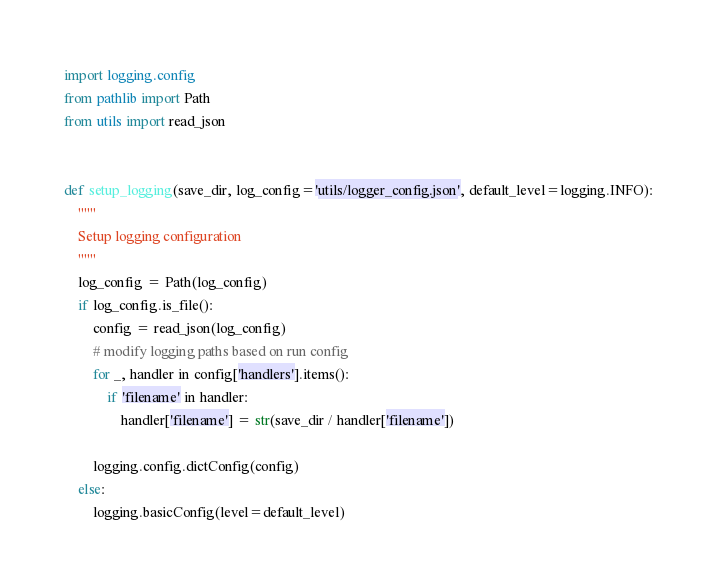<code> <loc_0><loc_0><loc_500><loc_500><_Python_>import logging.config
from pathlib import Path
from utils import read_json


def setup_logging(save_dir, log_config='utils/logger_config.json', default_level=logging.INFO):
    """
    Setup logging configuration
    """
    log_config = Path(log_config)
    if log_config.is_file():
        config = read_json(log_config)
        # modify logging paths based on run config
        for _, handler in config['handlers'].items():
            if 'filename' in handler:
                handler['filename'] = str(save_dir / handler['filename'])

        logging.config.dictConfig(config)
    else:
        logging.basicConfig(level=default_level)
</code> 